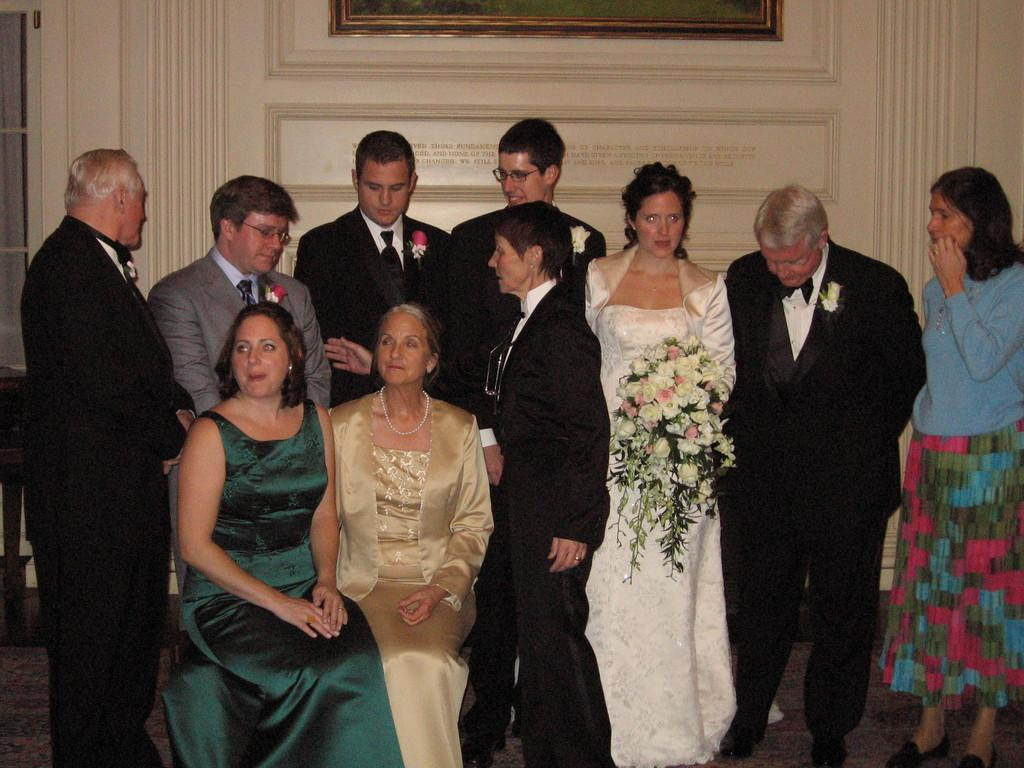What are the people in the image doing? The people in the image are sitting and standing in the center of the image. What can be seen in the background of the image? There is a door, a photo frame, and a wall in the background of the image. What type of wool is being used to create the argument in the image? There is no argument or wool present in the image. Where is the field located in the image? There is no field present in the image. 